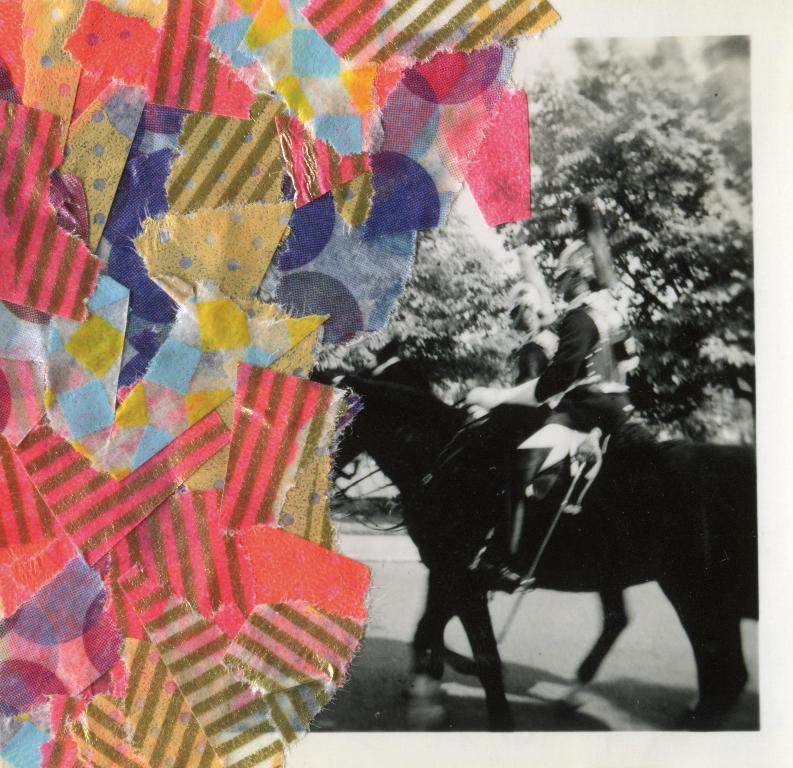What is the main subject of the image? There is a person riding a horse in the image. Where is the person located in the image? The person is on the right side of the image. What can be seen in the background of the image? There are trees beside the person. What is the colorful object visible on the left side of the image? There is a colorful paper visible on the left side of the image. What type of trousers is the person wearing while riding the horse? There is no information about the person's trousers in the image, so we cannot determine what type they are wearing. How much money can be seen in the image? There is no money visible in the image. 